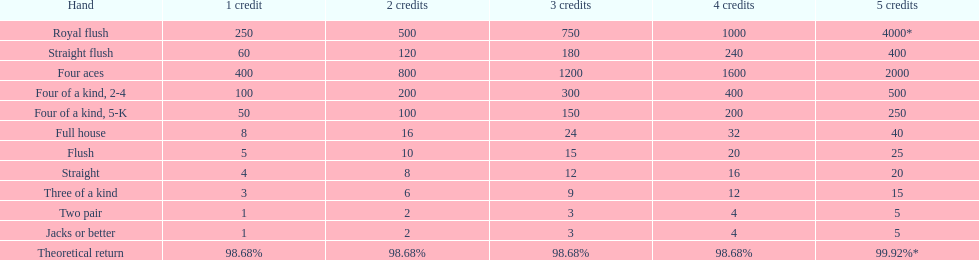Which variation of four of a kind offers the highest chances of victory? Four of a kind, 2-4. 